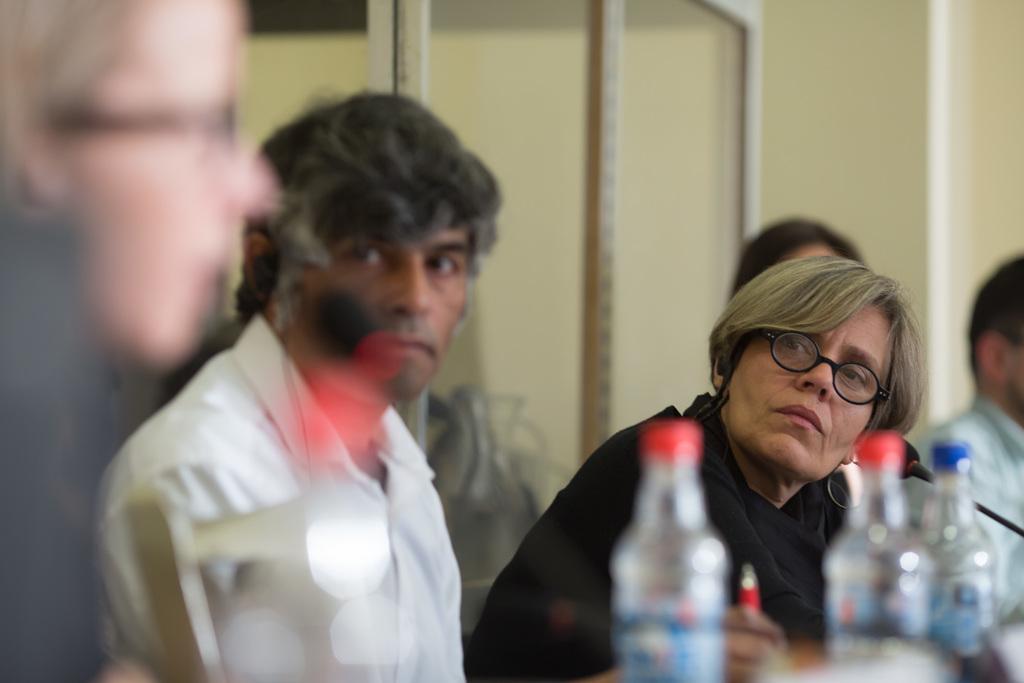Please provide a concise description of this image. In the image there is a woman sitting in front a mic and beside the woman few other people were also sitting but their images are blurred and beside the mic there are few water bottles. 